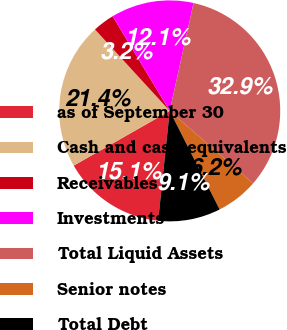Convert chart. <chart><loc_0><loc_0><loc_500><loc_500><pie_chart><fcel>as of September 30<fcel>Cash and cash equivalents<fcel>Receivables<fcel>Investments<fcel>Total Liquid Assets<fcel>Senior notes<fcel>Total Debt<nl><fcel>15.08%<fcel>21.43%<fcel>3.18%<fcel>12.1%<fcel>32.93%<fcel>6.15%<fcel>9.13%<nl></chart> 